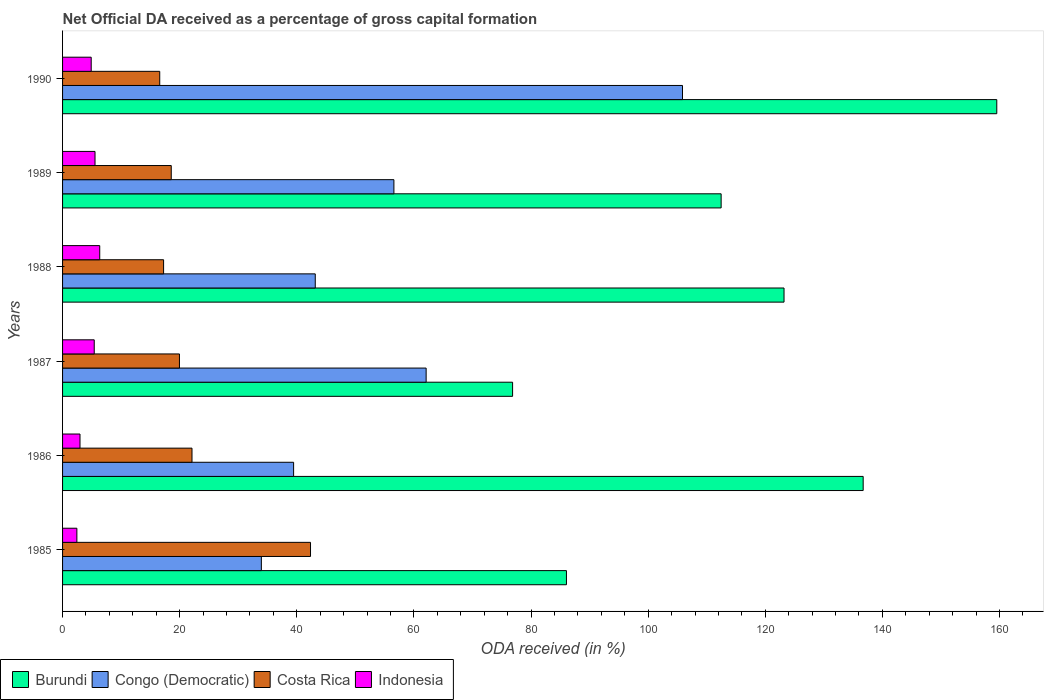How many different coloured bars are there?
Your response must be concise. 4. How many bars are there on the 1st tick from the bottom?
Provide a succinct answer. 4. What is the label of the 4th group of bars from the top?
Give a very brief answer. 1987. In how many cases, is the number of bars for a given year not equal to the number of legend labels?
Your response must be concise. 0. What is the net ODA received in Burundi in 1988?
Keep it short and to the point. 123.2. Across all years, what is the maximum net ODA received in Congo (Democratic)?
Offer a very short reply. 105.87. Across all years, what is the minimum net ODA received in Burundi?
Your answer should be compact. 76.85. In which year was the net ODA received in Congo (Democratic) maximum?
Your answer should be compact. 1990. What is the total net ODA received in Congo (Democratic) in the graph?
Give a very brief answer. 341.09. What is the difference between the net ODA received in Indonesia in 1986 and that in 1987?
Make the answer very short. -2.43. What is the difference between the net ODA received in Congo (Democratic) in 1990 and the net ODA received in Costa Rica in 1985?
Offer a very short reply. 63.52. What is the average net ODA received in Indonesia per year?
Offer a very short reply. 4.6. In the year 1990, what is the difference between the net ODA received in Indonesia and net ODA received in Costa Rica?
Offer a terse response. -11.7. In how many years, is the net ODA received in Burundi greater than 116 %?
Give a very brief answer. 3. What is the ratio of the net ODA received in Costa Rica in 1986 to that in 1988?
Give a very brief answer. 1.28. Is the net ODA received in Indonesia in 1986 less than that in 1990?
Your answer should be compact. Yes. What is the difference between the highest and the second highest net ODA received in Congo (Democratic)?
Your response must be concise. 43.78. What is the difference between the highest and the lowest net ODA received in Burundi?
Keep it short and to the point. 82.68. What does the 2nd bar from the top in 1987 represents?
Make the answer very short. Costa Rica. What does the 1st bar from the bottom in 1985 represents?
Keep it short and to the point. Burundi. Is it the case that in every year, the sum of the net ODA received in Burundi and net ODA received in Congo (Democratic) is greater than the net ODA received in Costa Rica?
Your answer should be very brief. Yes. How many bars are there?
Keep it short and to the point. 24. Are all the bars in the graph horizontal?
Offer a very short reply. Yes. How many years are there in the graph?
Your answer should be very brief. 6. Are the values on the major ticks of X-axis written in scientific E-notation?
Keep it short and to the point. No. Does the graph contain grids?
Give a very brief answer. No. How are the legend labels stacked?
Provide a short and direct response. Horizontal. What is the title of the graph?
Ensure brevity in your answer.  Net Official DA received as a percentage of gross capital formation. What is the label or title of the X-axis?
Your response must be concise. ODA received (in %). What is the label or title of the Y-axis?
Your answer should be compact. Years. What is the ODA received (in %) of Burundi in 1985?
Offer a terse response. 86.05. What is the ODA received (in %) of Congo (Democratic) in 1985?
Give a very brief answer. 33.95. What is the ODA received (in %) in Costa Rica in 1985?
Provide a succinct answer. 42.34. What is the ODA received (in %) in Indonesia in 1985?
Make the answer very short. 2.44. What is the ODA received (in %) of Burundi in 1986?
Your response must be concise. 136.72. What is the ODA received (in %) in Congo (Democratic) in 1986?
Ensure brevity in your answer.  39.45. What is the ODA received (in %) of Costa Rica in 1986?
Ensure brevity in your answer.  22.1. What is the ODA received (in %) in Indonesia in 1986?
Keep it short and to the point. 2.98. What is the ODA received (in %) of Burundi in 1987?
Offer a terse response. 76.85. What is the ODA received (in %) in Congo (Democratic) in 1987?
Offer a very short reply. 62.09. What is the ODA received (in %) of Costa Rica in 1987?
Provide a succinct answer. 19.96. What is the ODA received (in %) of Indonesia in 1987?
Provide a succinct answer. 5.41. What is the ODA received (in %) in Burundi in 1988?
Provide a short and direct response. 123.2. What is the ODA received (in %) in Congo (Democratic) in 1988?
Provide a succinct answer. 43.15. What is the ODA received (in %) in Costa Rica in 1988?
Provide a short and direct response. 17.25. What is the ODA received (in %) of Indonesia in 1988?
Keep it short and to the point. 6.35. What is the ODA received (in %) in Burundi in 1989?
Give a very brief answer. 112.46. What is the ODA received (in %) of Congo (Democratic) in 1989?
Keep it short and to the point. 56.58. What is the ODA received (in %) of Costa Rica in 1989?
Make the answer very short. 18.56. What is the ODA received (in %) of Indonesia in 1989?
Your response must be concise. 5.54. What is the ODA received (in %) of Burundi in 1990?
Offer a very short reply. 159.53. What is the ODA received (in %) in Congo (Democratic) in 1990?
Make the answer very short. 105.87. What is the ODA received (in %) in Costa Rica in 1990?
Offer a very short reply. 16.59. What is the ODA received (in %) in Indonesia in 1990?
Provide a succinct answer. 4.89. Across all years, what is the maximum ODA received (in %) of Burundi?
Keep it short and to the point. 159.53. Across all years, what is the maximum ODA received (in %) of Congo (Democratic)?
Ensure brevity in your answer.  105.87. Across all years, what is the maximum ODA received (in %) in Costa Rica?
Offer a very short reply. 42.34. Across all years, what is the maximum ODA received (in %) in Indonesia?
Your answer should be very brief. 6.35. Across all years, what is the minimum ODA received (in %) of Burundi?
Make the answer very short. 76.85. Across all years, what is the minimum ODA received (in %) of Congo (Democratic)?
Your response must be concise. 33.95. Across all years, what is the minimum ODA received (in %) in Costa Rica?
Your answer should be very brief. 16.59. Across all years, what is the minimum ODA received (in %) of Indonesia?
Offer a very short reply. 2.44. What is the total ODA received (in %) in Burundi in the graph?
Offer a very short reply. 694.81. What is the total ODA received (in %) in Congo (Democratic) in the graph?
Provide a short and direct response. 341.09. What is the total ODA received (in %) of Costa Rica in the graph?
Keep it short and to the point. 136.81. What is the total ODA received (in %) in Indonesia in the graph?
Keep it short and to the point. 27.61. What is the difference between the ODA received (in %) in Burundi in 1985 and that in 1986?
Keep it short and to the point. -50.67. What is the difference between the ODA received (in %) in Congo (Democratic) in 1985 and that in 1986?
Make the answer very short. -5.51. What is the difference between the ODA received (in %) of Costa Rica in 1985 and that in 1986?
Keep it short and to the point. 20.24. What is the difference between the ODA received (in %) in Indonesia in 1985 and that in 1986?
Make the answer very short. -0.53. What is the difference between the ODA received (in %) in Burundi in 1985 and that in 1987?
Give a very brief answer. 9.2. What is the difference between the ODA received (in %) of Congo (Democratic) in 1985 and that in 1987?
Keep it short and to the point. -28.14. What is the difference between the ODA received (in %) in Costa Rica in 1985 and that in 1987?
Keep it short and to the point. 22.38. What is the difference between the ODA received (in %) in Indonesia in 1985 and that in 1987?
Make the answer very short. -2.96. What is the difference between the ODA received (in %) of Burundi in 1985 and that in 1988?
Offer a terse response. -37.15. What is the difference between the ODA received (in %) of Congo (Democratic) in 1985 and that in 1988?
Make the answer very short. -9.21. What is the difference between the ODA received (in %) of Costa Rica in 1985 and that in 1988?
Make the answer very short. 25.09. What is the difference between the ODA received (in %) in Indonesia in 1985 and that in 1988?
Make the answer very short. -3.9. What is the difference between the ODA received (in %) in Burundi in 1985 and that in 1989?
Provide a succinct answer. -26.42. What is the difference between the ODA received (in %) in Congo (Democratic) in 1985 and that in 1989?
Your answer should be compact. -22.64. What is the difference between the ODA received (in %) of Costa Rica in 1985 and that in 1989?
Offer a very short reply. 23.78. What is the difference between the ODA received (in %) in Indonesia in 1985 and that in 1989?
Give a very brief answer. -3.1. What is the difference between the ODA received (in %) in Burundi in 1985 and that in 1990?
Keep it short and to the point. -73.49. What is the difference between the ODA received (in %) in Congo (Democratic) in 1985 and that in 1990?
Provide a short and direct response. -71.92. What is the difference between the ODA received (in %) of Costa Rica in 1985 and that in 1990?
Offer a terse response. 25.75. What is the difference between the ODA received (in %) of Indonesia in 1985 and that in 1990?
Give a very brief answer. -2.45. What is the difference between the ODA received (in %) in Burundi in 1986 and that in 1987?
Offer a very short reply. 59.87. What is the difference between the ODA received (in %) of Congo (Democratic) in 1986 and that in 1987?
Keep it short and to the point. -22.63. What is the difference between the ODA received (in %) of Costa Rica in 1986 and that in 1987?
Your answer should be very brief. 2.14. What is the difference between the ODA received (in %) in Indonesia in 1986 and that in 1987?
Your response must be concise. -2.43. What is the difference between the ODA received (in %) in Burundi in 1986 and that in 1988?
Keep it short and to the point. 13.51. What is the difference between the ODA received (in %) in Congo (Democratic) in 1986 and that in 1988?
Ensure brevity in your answer.  -3.7. What is the difference between the ODA received (in %) in Costa Rica in 1986 and that in 1988?
Your answer should be compact. 4.85. What is the difference between the ODA received (in %) in Indonesia in 1986 and that in 1988?
Your answer should be very brief. -3.37. What is the difference between the ODA received (in %) in Burundi in 1986 and that in 1989?
Your response must be concise. 24.25. What is the difference between the ODA received (in %) of Congo (Democratic) in 1986 and that in 1989?
Keep it short and to the point. -17.13. What is the difference between the ODA received (in %) of Costa Rica in 1986 and that in 1989?
Provide a succinct answer. 3.54. What is the difference between the ODA received (in %) of Indonesia in 1986 and that in 1989?
Offer a very short reply. -2.56. What is the difference between the ODA received (in %) in Burundi in 1986 and that in 1990?
Your response must be concise. -22.82. What is the difference between the ODA received (in %) of Congo (Democratic) in 1986 and that in 1990?
Your response must be concise. -66.41. What is the difference between the ODA received (in %) in Costa Rica in 1986 and that in 1990?
Provide a short and direct response. 5.51. What is the difference between the ODA received (in %) in Indonesia in 1986 and that in 1990?
Your answer should be compact. -1.91. What is the difference between the ODA received (in %) in Burundi in 1987 and that in 1988?
Your answer should be compact. -46.35. What is the difference between the ODA received (in %) in Congo (Democratic) in 1987 and that in 1988?
Offer a very short reply. 18.93. What is the difference between the ODA received (in %) in Costa Rica in 1987 and that in 1988?
Your response must be concise. 2.71. What is the difference between the ODA received (in %) of Indonesia in 1987 and that in 1988?
Offer a terse response. -0.94. What is the difference between the ODA received (in %) of Burundi in 1987 and that in 1989?
Provide a short and direct response. -35.61. What is the difference between the ODA received (in %) of Congo (Democratic) in 1987 and that in 1989?
Offer a terse response. 5.51. What is the difference between the ODA received (in %) of Costa Rica in 1987 and that in 1989?
Ensure brevity in your answer.  1.4. What is the difference between the ODA received (in %) in Indonesia in 1987 and that in 1989?
Make the answer very short. -0.13. What is the difference between the ODA received (in %) of Burundi in 1987 and that in 1990?
Your response must be concise. -82.68. What is the difference between the ODA received (in %) of Congo (Democratic) in 1987 and that in 1990?
Keep it short and to the point. -43.78. What is the difference between the ODA received (in %) of Costa Rica in 1987 and that in 1990?
Provide a short and direct response. 3.37. What is the difference between the ODA received (in %) in Indonesia in 1987 and that in 1990?
Your response must be concise. 0.52. What is the difference between the ODA received (in %) in Burundi in 1988 and that in 1989?
Provide a short and direct response. 10.74. What is the difference between the ODA received (in %) of Congo (Democratic) in 1988 and that in 1989?
Offer a terse response. -13.43. What is the difference between the ODA received (in %) of Costa Rica in 1988 and that in 1989?
Your answer should be very brief. -1.31. What is the difference between the ODA received (in %) of Indonesia in 1988 and that in 1989?
Provide a short and direct response. 0.81. What is the difference between the ODA received (in %) in Burundi in 1988 and that in 1990?
Give a very brief answer. -36.33. What is the difference between the ODA received (in %) in Congo (Democratic) in 1988 and that in 1990?
Make the answer very short. -62.71. What is the difference between the ODA received (in %) of Costa Rica in 1988 and that in 1990?
Your answer should be compact. 0.66. What is the difference between the ODA received (in %) of Indonesia in 1988 and that in 1990?
Your answer should be compact. 1.46. What is the difference between the ODA received (in %) in Burundi in 1989 and that in 1990?
Your answer should be very brief. -47.07. What is the difference between the ODA received (in %) in Congo (Democratic) in 1989 and that in 1990?
Provide a short and direct response. -49.28. What is the difference between the ODA received (in %) of Costa Rica in 1989 and that in 1990?
Your answer should be very brief. 1.97. What is the difference between the ODA received (in %) in Indonesia in 1989 and that in 1990?
Offer a terse response. 0.65. What is the difference between the ODA received (in %) in Burundi in 1985 and the ODA received (in %) in Congo (Democratic) in 1986?
Offer a terse response. 46.59. What is the difference between the ODA received (in %) in Burundi in 1985 and the ODA received (in %) in Costa Rica in 1986?
Provide a succinct answer. 63.95. What is the difference between the ODA received (in %) of Burundi in 1985 and the ODA received (in %) of Indonesia in 1986?
Provide a succinct answer. 83.07. What is the difference between the ODA received (in %) of Congo (Democratic) in 1985 and the ODA received (in %) of Costa Rica in 1986?
Make the answer very short. 11.84. What is the difference between the ODA received (in %) of Congo (Democratic) in 1985 and the ODA received (in %) of Indonesia in 1986?
Make the answer very short. 30.97. What is the difference between the ODA received (in %) of Costa Rica in 1985 and the ODA received (in %) of Indonesia in 1986?
Offer a terse response. 39.36. What is the difference between the ODA received (in %) of Burundi in 1985 and the ODA received (in %) of Congo (Democratic) in 1987?
Ensure brevity in your answer.  23.96. What is the difference between the ODA received (in %) in Burundi in 1985 and the ODA received (in %) in Costa Rica in 1987?
Provide a succinct answer. 66.09. What is the difference between the ODA received (in %) of Burundi in 1985 and the ODA received (in %) of Indonesia in 1987?
Your response must be concise. 80.64. What is the difference between the ODA received (in %) of Congo (Democratic) in 1985 and the ODA received (in %) of Costa Rica in 1987?
Offer a very short reply. 13.99. What is the difference between the ODA received (in %) in Congo (Democratic) in 1985 and the ODA received (in %) in Indonesia in 1987?
Your response must be concise. 28.54. What is the difference between the ODA received (in %) of Costa Rica in 1985 and the ODA received (in %) of Indonesia in 1987?
Ensure brevity in your answer.  36.94. What is the difference between the ODA received (in %) of Burundi in 1985 and the ODA received (in %) of Congo (Democratic) in 1988?
Offer a very short reply. 42.9. What is the difference between the ODA received (in %) in Burundi in 1985 and the ODA received (in %) in Costa Rica in 1988?
Your answer should be compact. 68.79. What is the difference between the ODA received (in %) in Burundi in 1985 and the ODA received (in %) in Indonesia in 1988?
Keep it short and to the point. 79.7. What is the difference between the ODA received (in %) of Congo (Democratic) in 1985 and the ODA received (in %) of Costa Rica in 1988?
Your response must be concise. 16.69. What is the difference between the ODA received (in %) of Congo (Democratic) in 1985 and the ODA received (in %) of Indonesia in 1988?
Provide a short and direct response. 27.6. What is the difference between the ODA received (in %) in Costa Rica in 1985 and the ODA received (in %) in Indonesia in 1988?
Provide a succinct answer. 35.99. What is the difference between the ODA received (in %) of Burundi in 1985 and the ODA received (in %) of Congo (Democratic) in 1989?
Offer a very short reply. 29.47. What is the difference between the ODA received (in %) in Burundi in 1985 and the ODA received (in %) in Costa Rica in 1989?
Provide a succinct answer. 67.49. What is the difference between the ODA received (in %) in Burundi in 1985 and the ODA received (in %) in Indonesia in 1989?
Your response must be concise. 80.51. What is the difference between the ODA received (in %) of Congo (Democratic) in 1985 and the ODA received (in %) of Costa Rica in 1989?
Provide a succinct answer. 15.39. What is the difference between the ODA received (in %) of Congo (Democratic) in 1985 and the ODA received (in %) of Indonesia in 1989?
Offer a very short reply. 28.4. What is the difference between the ODA received (in %) in Costa Rica in 1985 and the ODA received (in %) in Indonesia in 1989?
Ensure brevity in your answer.  36.8. What is the difference between the ODA received (in %) of Burundi in 1985 and the ODA received (in %) of Congo (Democratic) in 1990?
Your answer should be compact. -19.82. What is the difference between the ODA received (in %) in Burundi in 1985 and the ODA received (in %) in Costa Rica in 1990?
Give a very brief answer. 69.46. What is the difference between the ODA received (in %) of Burundi in 1985 and the ODA received (in %) of Indonesia in 1990?
Your answer should be compact. 81.16. What is the difference between the ODA received (in %) of Congo (Democratic) in 1985 and the ODA received (in %) of Costa Rica in 1990?
Your response must be concise. 17.35. What is the difference between the ODA received (in %) in Congo (Democratic) in 1985 and the ODA received (in %) in Indonesia in 1990?
Offer a terse response. 29.06. What is the difference between the ODA received (in %) in Costa Rica in 1985 and the ODA received (in %) in Indonesia in 1990?
Your answer should be very brief. 37.45. What is the difference between the ODA received (in %) in Burundi in 1986 and the ODA received (in %) in Congo (Democratic) in 1987?
Your answer should be very brief. 74.63. What is the difference between the ODA received (in %) in Burundi in 1986 and the ODA received (in %) in Costa Rica in 1987?
Your response must be concise. 116.76. What is the difference between the ODA received (in %) in Burundi in 1986 and the ODA received (in %) in Indonesia in 1987?
Your answer should be compact. 131.31. What is the difference between the ODA received (in %) of Congo (Democratic) in 1986 and the ODA received (in %) of Costa Rica in 1987?
Ensure brevity in your answer.  19.49. What is the difference between the ODA received (in %) of Congo (Democratic) in 1986 and the ODA received (in %) of Indonesia in 1987?
Your answer should be very brief. 34.05. What is the difference between the ODA received (in %) in Costa Rica in 1986 and the ODA received (in %) in Indonesia in 1987?
Your response must be concise. 16.7. What is the difference between the ODA received (in %) of Burundi in 1986 and the ODA received (in %) of Congo (Democratic) in 1988?
Make the answer very short. 93.56. What is the difference between the ODA received (in %) of Burundi in 1986 and the ODA received (in %) of Costa Rica in 1988?
Give a very brief answer. 119.46. What is the difference between the ODA received (in %) of Burundi in 1986 and the ODA received (in %) of Indonesia in 1988?
Your answer should be compact. 130.37. What is the difference between the ODA received (in %) of Congo (Democratic) in 1986 and the ODA received (in %) of Costa Rica in 1988?
Offer a terse response. 22.2. What is the difference between the ODA received (in %) in Congo (Democratic) in 1986 and the ODA received (in %) in Indonesia in 1988?
Keep it short and to the point. 33.11. What is the difference between the ODA received (in %) in Costa Rica in 1986 and the ODA received (in %) in Indonesia in 1988?
Make the answer very short. 15.75. What is the difference between the ODA received (in %) in Burundi in 1986 and the ODA received (in %) in Congo (Democratic) in 1989?
Offer a terse response. 80.14. What is the difference between the ODA received (in %) of Burundi in 1986 and the ODA received (in %) of Costa Rica in 1989?
Your answer should be compact. 118.16. What is the difference between the ODA received (in %) of Burundi in 1986 and the ODA received (in %) of Indonesia in 1989?
Keep it short and to the point. 131.18. What is the difference between the ODA received (in %) in Congo (Democratic) in 1986 and the ODA received (in %) in Costa Rica in 1989?
Provide a short and direct response. 20.89. What is the difference between the ODA received (in %) of Congo (Democratic) in 1986 and the ODA received (in %) of Indonesia in 1989?
Provide a short and direct response. 33.91. What is the difference between the ODA received (in %) in Costa Rica in 1986 and the ODA received (in %) in Indonesia in 1989?
Give a very brief answer. 16.56. What is the difference between the ODA received (in %) in Burundi in 1986 and the ODA received (in %) in Congo (Democratic) in 1990?
Keep it short and to the point. 30.85. What is the difference between the ODA received (in %) in Burundi in 1986 and the ODA received (in %) in Costa Rica in 1990?
Provide a succinct answer. 120.12. What is the difference between the ODA received (in %) of Burundi in 1986 and the ODA received (in %) of Indonesia in 1990?
Offer a very short reply. 131.83. What is the difference between the ODA received (in %) in Congo (Democratic) in 1986 and the ODA received (in %) in Costa Rica in 1990?
Your answer should be compact. 22.86. What is the difference between the ODA received (in %) of Congo (Democratic) in 1986 and the ODA received (in %) of Indonesia in 1990?
Make the answer very short. 34.56. What is the difference between the ODA received (in %) in Costa Rica in 1986 and the ODA received (in %) in Indonesia in 1990?
Give a very brief answer. 17.21. What is the difference between the ODA received (in %) of Burundi in 1987 and the ODA received (in %) of Congo (Democratic) in 1988?
Give a very brief answer. 33.7. What is the difference between the ODA received (in %) in Burundi in 1987 and the ODA received (in %) in Costa Rica in 1988?
Your answer should be very brief. 59.6. What is the difference between the ODA received (in %) in Burundi in 1987 and the ODA received (in %) in Indonesia in 1988?
Offer a very short reply. 70.5. What is the difference between the ODA received (in %) in Congo (Democratic) in 1987 and the ODA received (in %) in Costa Rica in 1988?
Offer a very short reply. 44.83. What is the difference between the ODA received (in %) of Congo (Democratic) in 1987 and the ODA received (in %) of Indonesia in 1988?
Offer a very short reply. 55.74. What is the difference between the ODA received (in %) of Costa Rica in 1987 and the ODA received (in %) of Indonesia in 1988?
Offer a terse response. 13.61. What is the difference between the ODA received (in %) in Burundi in 1987 and the ODA received (in %) in Congo (Democratic) in 1989?
Your answer should be very brief. 20.27. What is the difference between the ODA received (in %) of Burundi in 1987 and the ODA received (in %) of Costa Rica in 1989?
Provide a succinct answer. 58.29. What is the difference between the ODA received (in %) of Burundi in 1987 and the ODA received (in %) of Indonesia in 1989?
Keep it short and to the point. 71.31. What is the difference between the ODA received (in %) in Congo (Democratic) in 1987 and the ODA received (in %) in Costa Rica in 1989?
Ensure brevity in your answer.  43.53. What is the difference between the ODA received (in %) of Congo (Democratic) in 1987 and the ODA received (in %) of Indonesia in 1989?
Your response must be concise. 56.54. What is the difference between the ODA received (in %) in Costa Rica in 1987 and the ODA received (in %) in Indonesia in 1989?
Provide a succinct answer. 14.42. What is the difference between the ODA received (in %) of Burundi in 1987 and the ODA received (in %) of Congo (Democratic) in 1990?
Ensure brevity in your answer.  -29.02. What is the difference between the ODA received (in %) of Burundi in 1987 and the ODA received (in %) of Costa Rica in 1990?
Provide a succinct answer. 60.26. What is the difference between the ODA received (in %) in Burundi in 1987 and the ODA received (in %) in Indonesia in 1990?
Keep it short and to the point. 71.96. What is the difference between the ODA received (in %) in Congo (Democratic) in 1987 and the ODA received (in %) in Costa Rica in 1990?
Keep it short and to the point. 45.49. What is the difference between the ODA received (in %) of Congo (Democratic) in 1987 and the ODA received (in %) of Indonesia in 1990?
Keep it short and to the point. 57.2. What is the difference between the ODA received (in %) in Costa Rica in 1987 and the ODA received (in %) in Indonesia in 1990?
Offer a terse response. 15.07. What is the difference between the ODA received (in %) in Burundi in 1988 and the ODA received (in %) in Congo (Democratic) in 1989?
Your answer should be compact. 66.62. What is the difference between the ODA received (in %) in Burundi in 1988 and the ODA received (in %) in Costa Rica in 1989?
Offer a very short reply. 104.64. What is the difference between the ODA received (in %) in Burundi in 1988 and the ODA received (in %) in Indonesia in 1989?
Provide a short and direct response. 117.66. What is the difference between the ODA received (in %) in Congo (Democratic) in 1988 and the ODA received (in %) in Costa Rica in 1989?
Ensure brevity in your answer.  24.59. What is the difference between the ODA received (in %) of Congo (Democratic) in 1988 and the ODA received (in %) of Indonesia in 1989?
Give a very brief answer. 37.61. What is the difference between the ODA received (in %) of Costa Rica in 1988 and the ODA received (in %) of Indonesia in 1989?
Keep it short and to the point. 11.71. What is the difference between the ODA received (in %) of Burundi in 1988 and the ODA received (in %) of Congo (Democratic) in 1990?
Ensure brevity in your answer.  17.34. What is the difference between the ODA received (in %) of Burundi in 1988 and the ODA received (in %) of Costa Rica in 1990?
Your answer should be compact. 106.61. What is the difference between the ODA received (in %) of Burundi in 1988 and the ODA received (in %) of Indonesia in 1990?
Offer a very short reply. 118.31. What is the difference between the ODA received (in %) in Congo (Democratic) in 1988 and the ODA received (in %) in Costa Rica in 1990?
Provide a short and direct response. 26.56. What is the difference between the ODA received (in %) of Congo (Democratic) in 1988 and the ODA received (in %) of Indonesia in 1990?
Provide a succinct answer. 38.26. What is the difference between the ODA received (in %) of Costa Rica in 1988 and the ODA received (in %) of Indonesia in 1990?
Ensure brevity in your answer.  12.36. What is the difference between the ODA received (in %) in Burundi in 1989 and the ODA received (in %) in Congo (Democratic) in 1990?
Provide a short and direct response. 6.6. What is the difference between the ODA received (in %) of Burundi in 1989 and the ODA received (in %) of Costa Rica in 1990?
Keep it short and to the point. 95.87. What is the difference between the ODA received (in %) of Burundi in 1989 and the ODA received (in %) of Indonesia in 1990?
Keep it short and to the point. 107.57. What is the difference between the ODA received (in %) in Congo (Democratic) in 1989 and the ODA received (in %) in Costa Rica in 1990?
Your answer should be very brief. 39.99. What is the difference between the ODA received (in %) in Congo (Democratic) in 1989 and the ODA received (in %) in Indonesia in 1990?
Provide a short and direct response. 51.69. What is the difference between the ODA received (in %) in Costa Rica in 1989 and the ODA received (in %) in Indonesia in 1990?
Provide a succinct answer. 13.67. What is the average ODA received (in %) of Burundi per year?
Your answer should be compact. 115.8. What is the average ODA received (in %) of Congo (Democratic) per year?
Keep it short and to the point. 56.85. What is the average ODA received (in %) of Costa Rica per year?
Your answer should be compact. 22.8. What is the average ODA received (in %) in Indonesia per year?
Your answer should be very brief. 4.6. In the year 1985, what is the difference between the ODA received (in %) of Burundi and ODA received (in %) of Congo (Democratic)?
Your response must be concise. 52.1. In the year 1985, what is the difference between the ODA received (in %) of Burundi and ODA received (in %) of Costa Rica?
Your answer should be very brief. 43.71. In the year 1985, what is the difference between the ODA received (in %) of Burundi and ODA received (in %) of Indonesia?
Provide a succinct answer. 83.6. In the year 1985, what is the difference between the ODA received (in %) of Congo (Democratic) and ODA received (in %) of Costa Rica?
Make the answer very short. -8.4. In the year 1985, what is the difference between the ODA received (in %) in Congo (Democratic) and ODA received (in %) in Indonesia?
Ensure brevity in your answer.  31.5. In the year 1985, what is the difference between the ODA received (in %) of Costa Rica and ODA received (in %) of Indonesia?
Give a very brief answer. 39.9. In the year 1986, what is the difference between the ODA received (in %) of Burundi and ODA received (in %) of Congo (Democratic)?
Your answer should be very brief. 97.26. In the year 1986, what is the difference between the ODA received (in %) in Burundi and ODA received (in %) in Costa Rica?
Keep it short and to the point. 114.61. In the year 1986, what is the difference between the ODA received (in %) of Burundi and ODA received (in %) of Indonesia?
Provide a short and direct response. 133.74. In the year 1986, what is the difference between the ODA received (in %) in Congo (Democratic) and ODA received (in %) in Costa Rica?
Provide a succinct answer. 17.35. In the year 1986, what is the difference between the ODA received (in %) of Congo (Democratic) and ODA received (in %) of Indonesia?
Keep it short and to the point. 36.48. In the year 1986, what is the difference between the ODA received (in %) of Costa Rica and ODA received (in %) of Indonesia?
Make the answer very short. 19.12. In the year 1987, what is the difference between the ODA received (in %) in Burundi and ODA received (in %) in Congo (Democratic)?
Offer a very short reply. 14.76. In the year 1987, what is the difference between the ODA received (in %) in Burundi and ODA received (in %) in Costa Rica?
Give a very brief answer. 56.89. In the year 1987, what is the difference between the ODA received (in %) in Burundi and ODA received (in %) in Indonesia?
Your answer should be very brief. 71.44. In the year 1987, what is the difference between the ODA received (in %) of Congo (Democratic) and ODA received (in %) of Costa Rica?
Provide a short and direct response. 42.13. In the year 1987, what is the difference between the ODA received (in %) in Congo (Democratic) and ODA received (in %) in Indonesia?
Your response must be concise. 56.68. In the year 1987, what is the difference between the ODA received (in %) in Costa Rica and ODA received (in %) in Indonesia?
Ensure brevity in your answer.  14.55. In the year 1988, what is the difference between the ODA received (in %) in Burundi and ODA received (in %) in Congo (Democratic)?
Make the answer very short. 80.05. In the year 1988, what is the difference between the ODA received (in %) of Burundi and ODA received (in %) of Costa Rica?
Your answer should be compact. 105.95. In the year 1988, what is the difference between the ODA received (in %) of Burundi and ODA received (in %) of Indonesia?
Your answer should be very brief. 116.85. In the year 1988, what is the difference between the ODA received (in %) in Congo (Democratic) and ODA received (in %) in Costa Rica?
Offer a terse response. 25.9. In the year 1988, what is the difference between the ODA received (in %) of Congo (Democratic) and ODA received (in %) of Indonesia?
Ensure brevity in your answer.  36.8. In the year 1988, what is the difference between the ODA received (in %) of Costa Rica and ODA received (in %) of Indonesia?
Your answer should be compact. 10.91. In the year 1989, what is the difference between the ODA received (in %) in Burundi and ODA received (in %) in Congo (Democratic)?
Your answer should be very brief. 55.88. In the year 1989, what is the difference between the ODA received (in %) in Burundi and ODA received (in %) in Costa Rica?
Provide a succinct answer. 93.9. In the year 1989, what is the difference between the ODA received (in %) in Burundi and ODA received (in %) in Indonesia?
Your response must be concise. 106.92. In the year 1989, what is the difference between the ODA received (in %) of Congo (Democratic) and ODA received (in %) of Costa Rica?
Keep it short and to the point. 38.02. In the year 1989, what is the difference between the ODA received (in %) of Congo (Democratic) and ODA received (in %) of Indonesia?
Provide a succinct answer. 51.04. In the year 1989, what is the difference between the ODA received (in %) of Costa Rica and ODA received (in %) of Indonesia?
Offer a very short reply. 13.02. In the year 1990, what is the difference between the ODA received (in %) of Burundi and ODA received (in %) of Congo (Democratic)?
Your response must be concise. 53.67. In the year 1990, what is the difference between the ODA received (in %) in Burundi and ODA received (in %) in Costa Rica?
Make the answer very short. 142.94. In the year 1990, what is the difference between the ODA received (in %) in Burundi and ODA received (in %) in Indonesia?
Provide a succinct answer. 154.64. In the year 1990, what is the difference between the ODA received (in %) in Congo (Democratic) and ODA received (in %) in Costa Rica?
Offer a terse response. 89.27. In the year 1990, what is the difference between the ODA received (in %) of Congo (Democratic) and ODA received (in %) of Indonesia?
Give a very brief answer. 100.98. In the year 1990, what is the difference between the ODA received (in %) of Costa Rica and ODA received (in %) of Indonesia?
Your answer should be compact. 11.7. What is the ratio of the ODA received (in %) of Burundi in 1985 to that in 1986?
Offer a very short reply. 0.63. What is the ratio of the ODA received (in %) in Congo (Democratic) in 1985 to that in 1986?
Keep it short and to the point. 0.86. What is the ratio of the ODA received (in %) in Costa Rica in 1985 to that in 1986?
Provide a short and direct response. 1.92. What is the ratio of the ODA received (in %) of Indonesia in 1985 to that in 1986?
Keep it short and to the point. 0.82. What is the ratio of the ODA received (in %) of Burundi in 1985 to that in 1987?
Keep it short and to the point. 1.12. What is the ratio of the ODA received (in %) of Congo (Democratic) in 1985 to that in 1987?
Provide a succinct answer. 0.55. What is the ratio of the ODA received (in %) of Costa Rica in 1985 to that in 1987?
Keep it short and to the point. 2.12. What is the ratio of the ODA received (in %) in Indonesia in 1985 to that in 1987?
Offer a very short reply. 0.45. What is the ratio of the ODA received (in %) in Burundi in 1985 to that in 1988?
Offer a terse response. 0.7. What is the ratio of the ODA received (in %) in Congo (Democratic) in 1985 to that in 1988?
Provide a succinct answer. 0.79. What is the ratio of the ODA received (in %) in Costa Rica in 1985 to that in 1988?
Provide a short and direct response. 2.45. What is the ratio of the ODA received (in %) of Indonesia in 1985 to that in 1988?
Offer a terse response. 0.39. What is the ratio of the ODA received (in %) of Burundi in 1985 to that in 1989?
Give a very brief answer. 0.77. What is the ratio of the ODA received (in %) of Congo (Democratic) in 1985 to that in 1989?
Offer a terse response. 0.6. What is the ratio of the ODA received (in %) of Costa Rica in 1985 to that in 1989?
Keep it short and to the point. 2.28. What is the ratio of the ODA received (in %) in Indonesia in 1985 to that in 1989?
Give a very brief answer. 0.44. What is the ratio of the ODA received (in %) in Burundi in 1985 to that in 1990?
Ensure brevity in your answer.  0.54. What is the ratio of the ODA received (in %) in Congo (Democratic) in 1985 to that in 1990?
Your response must be concise. 0.32. What is the ratio of the ODA received (in %) of Costa Rica in 1985 to that in 1990?
Keep it short and to the point. 2.55. What is the ratio of the ODA received (in %) of Indonesia in 1985 to that in 1990?
Your response must be concise. 0.5. What is the ratio of the ODA received (in %) in Burundi in 1986 to that in 1987?
Your answer should be compact. 1.78. What is the ratio of the ODA received (in %) of Congo (Democratic) in 1986 to that in 1987?
Your answer should be very brief. 0.64. What is the ratio of the ODA received (in %) in Costa Rica in 1986 to that in 1987?
Give a very brief answer. 1.11. What is the ratio of the ODA received (in %) of Indonesia in 1986 to that in 1987?
Keep it short and to the point. 0.55. What is the ratio of the ODA received (in %) of Burundi in 1986 to that in 1988?
Offer a very short reply. 1.11. What is the ratio of the ODA received (in %) of Congo (Democratic) in 1986 to that in 1988?
Your response must be concise. 0.91. What is the ratio of the ODA received (in %) in Costa Rica in 1986 to that in 1988?
Provide a short and direct response. 1.28. What is the ratio of the ODA received (in %) in Indonesia in 1986 to that in 1988?
Your answer should be compact. 0.47. What is the ratio of the ODA received (in %) in Burundi in 1986 to that in 1989?
Give a very brief answer. 1.22. What is the ratio of the ODA received (in %) of Congo (Democratic) in 1986 to that in 1989?
Give a very brief answer. 0.7. What is the ratio of the ODA received (in %) of Costa Rica in 1986 to that in 1989?
Make the answer very short. 1.19. What is the ratio of the ODA received (in %) of Indonesia in 1986 to that in 1989?
Provide a short and direct response. 0.54. What is the ratio of the ODA received (in %) of Burundi in 1986 to that in 1990?
Give a very brief answer. 0.86. What is the ratio of the ODA received (in %) of Congo (Democratic) in 1986 to that in 1990?
Ensure brevity in your answer.  0.37. What is the ratio of the ODA received (in %) of Costa Rica in 1986 to that in 1990?
Offer a very short reply. 1.33. What is the ratio of the ODA received (in %) in Indonesia in 1986 to that in 1990?
Ensure brevity in your answer.  0.61. What is the ratio of the ODA received (in %) in Burundi in 1987 to that in 1988?
Provide a succinct answer. 0.62. What is the ratio of the ODA received (in %) of Congo (Democratic) in 1987 to that in 1988?
Keep it short and to the point. 1.44. What is the ratio of the ODA received (in %) in Costa Rica in 1987 to that in 1988?
Give a very brief answer. 1.16. What is the ratio of the ODA received (in %) in Indonesia in 1987 to that in 1988?
Provide a short and direct response. 0.85. What is the ratio of the ODA received (in %) in Burundi in 1987 to that in 1989?
Your answer should be very brief. 0.68. What is the ratio of the ODA received (in %) of Congo (Democratic) in 1987 to that in 1989?
Offer a terse response. 1.1. What is the ratio of the ODA received (in %) in Costa Rica in 1987 to that in 1989?
Give a very brief answer. 1.08. What is the ratio of the ODA received (in %) of Indonesia in 1987 to that in 1989?
Provide a short and direct response. 0.98. What is the ratio of the ODA received (in %) in Burundi in 1987 to that in 1990?
Keep it short and to the point. 0.48. What is the ratio of the ODA received (in %) in Congo (Democratic) in 1987 to that in 1990?
Give a very brief answer. 0.59. What is the ratio of the ODA received (in %) in Costa Rica in 1987 to that in 1990?
Provide a short and direct response. 1.2. What is the ratio of the ODA received (in %) of Indonesia in 1987 to that in 1990?
Give a very brief answer. 1.11. What is the ratio of the ODA received (in %) of Burundi in 1988 to that in 1989?
Keep it short and to the point. 1.1. What is the ratio of the ODA received (in %) in Congo (Democratic) in 1988 to that in 1989?
Your answer should be compact. 0.76. What is the ratio of the ODA received (in %) in Costa Rica in 1988 to that in 1989?
Your answer should be very brief. 0.93. What is the ratio of the ODA received (in %) of Indonesia in 1988 to that in 1989?
Your answer should be very brief. 1.15. What is the ratio of the ODA received (in %) of Burundi in 1988 to that in 1990?
Keep it short and to the point. 0.77. What is the ratio of the ODA received (in %) of Congo (Democratic) in 1988 to that in 1990?
Your answer should be very brief. 0.41. What is the ratio of the ODA received (in %) in Costa Rica in 1988 to that in 1990?
Your answer should be very brief. 1.04. What is the ratio of the ODA received (in %) in Indonesia in 1988 to that in 1990?
Your answer should be very brief. 1.3. What is the ratio of the ODA received (in %) of Burundi in 1989 to that in 1990?
Offer a very short reply. 0.7. What is the ratio of the ODA received (in %) of Congo (Democratic) in 1989 to that in 1990?
Keep it short and to the point. 0.53. What is the ratio of the ODA received (in %) of Costa Rica in 1989 to that in 1990?
Provide a succinct answer. 1.12. What is the ratio of the ODA received (in %) of Indonesia in 1989 to that in 1990?
Offer a very short reply. 1.13. What is the difference between the highest and the second highest ODA received (in %) of Burundi?
Your response must be concise. 22.82. What is the difference between the highest and the second highest ODA received (in %) in Congo (Democratic)?
Offer a very short reply. 43.78. What is the difference between the highest and the second highest ODA received (in %) in Costa Rica?
Provide a succinct answer. 20.24. What is the difference between the highest and the second highest ODA received (in %) of Indonesia?
Offer a very short reply. 0.81. What is the difference between the highest and the lowest ODA received (in %) of Burundi?
Offer a terse response. 82.68. What is the difference between the highest and the lowest ODA received (in %) in Congo (Democratic)?
Make the answer very short. 71.92. What is the difference between the highest and the lowest ODA received (in %) in Costa Rica?
Give a very brief answer. 25.75. What is the difference between the highest and the lowest ODA received (in %) in Indonesia?
Offer a terse response. 3.9. 